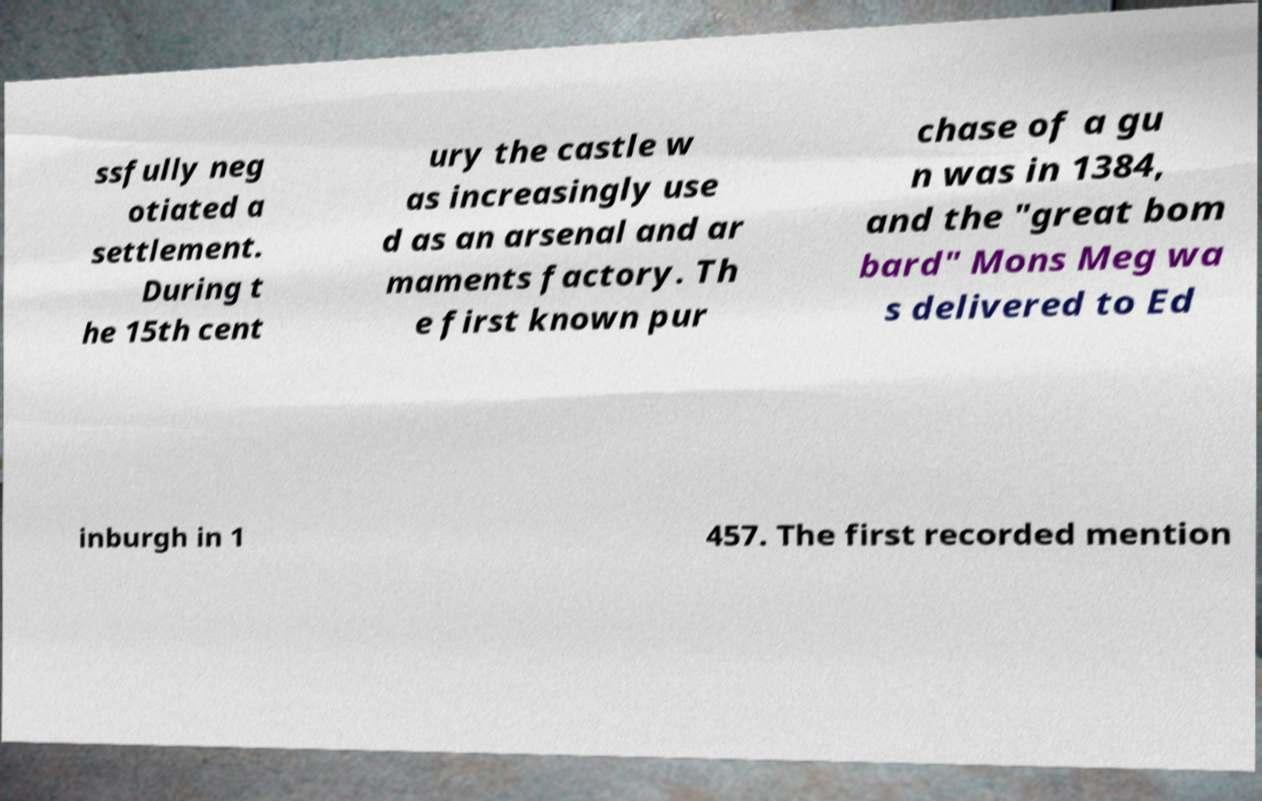Could you assist in decoding the text presented in this image and type it out clearly? ssfully neg otiated a settlement. During t he 15th cent ury the castle w as increasingly use d as an arsenal and ar maments factory. Th e first known pur chase of a gu n was in 1384, and the "great bom bard" Mons Meg wa s delivered to Ed inburgh in 1 457. The first recorded mention 